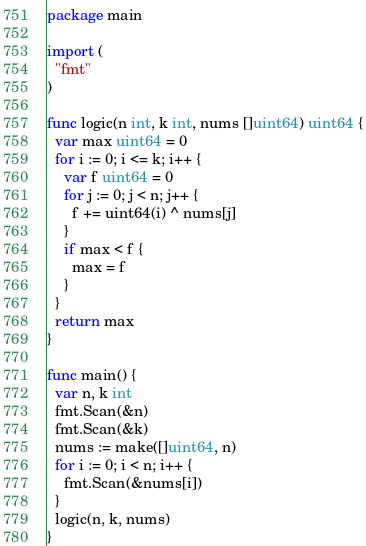Convert code to text. <code><loc_0><loc_0><loc_500><loc_500><_Go_>package main

import (
  "fmt"
)

func logic(n int, k int, nums []uint64) uint64 {
  var max uint64 = 0
  for i := 0; i <= k; i++ {
    var f uint64 = 0
    for j := 0; j < n; j++ {
      f += uint64(i) ^ nums[j]
    }
    if max < f {
      max = f
    }
  }
  return max
}

func main() {
  var n, k int
  fmt.Scan(&n)
  fmt.Scan(&k)
  nums := make([]uint64, n)
  for i := 0; i < n; i++ {
    fmt.Scan(&nums[i])
  }
  logic(n, k, nums)
}
</code> 